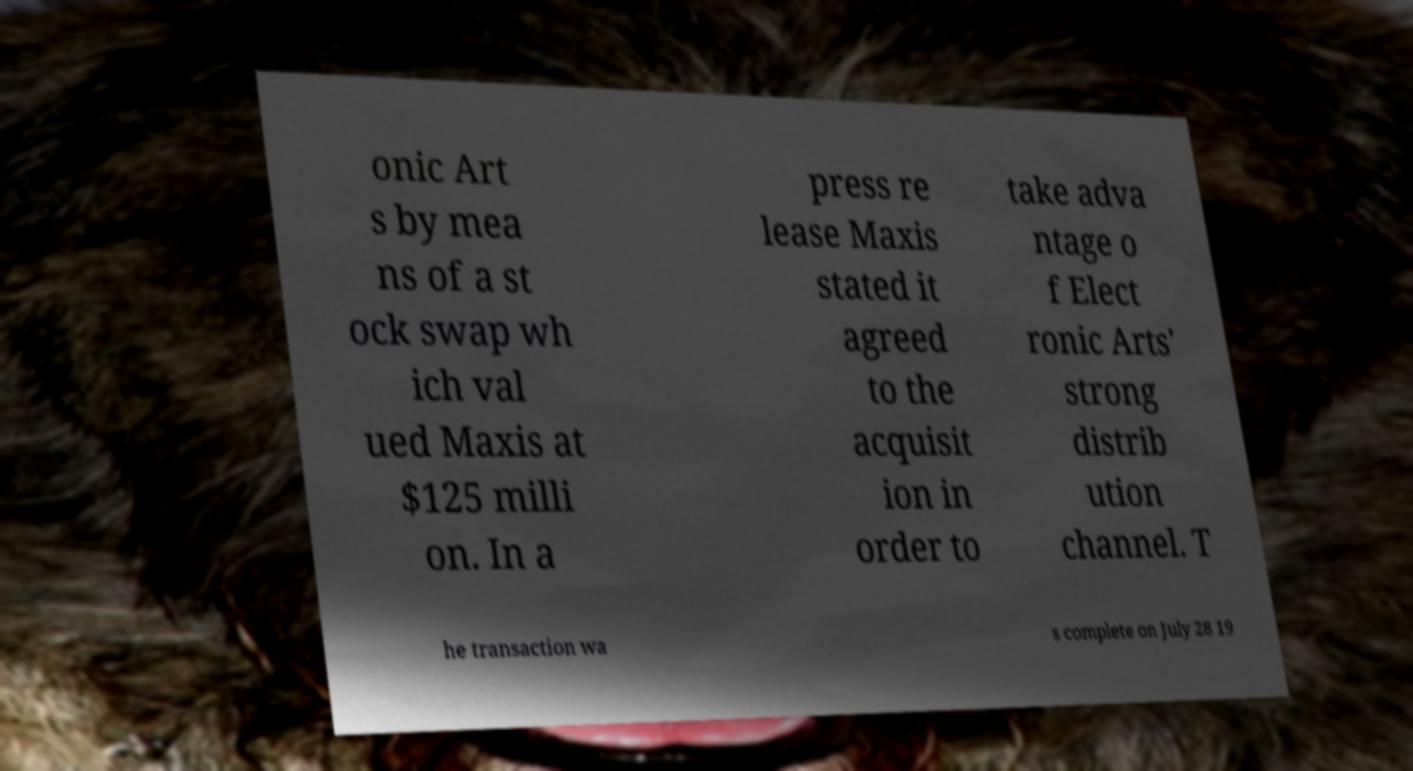Can you read and provide the text displayed in the image?This photo seems to have some interesting text. Can you extract and type it out for me? onic Art s by mea ns of a st ock swap wh ich val ued Maxis at $125 milli on. In a press re lease Maxis stated it agreed to the acquisit ion in order to take adva ntage o f Elect ronic Arts' strong distrib ution channel. T he transaction wa s complete on July 28 19 